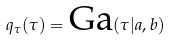<formula> <loc_0><loc_0><loc_500><loc_500>q _ { \tau } ( \tau ) = \text {Ga} ( \tau | a , b )</formula> 